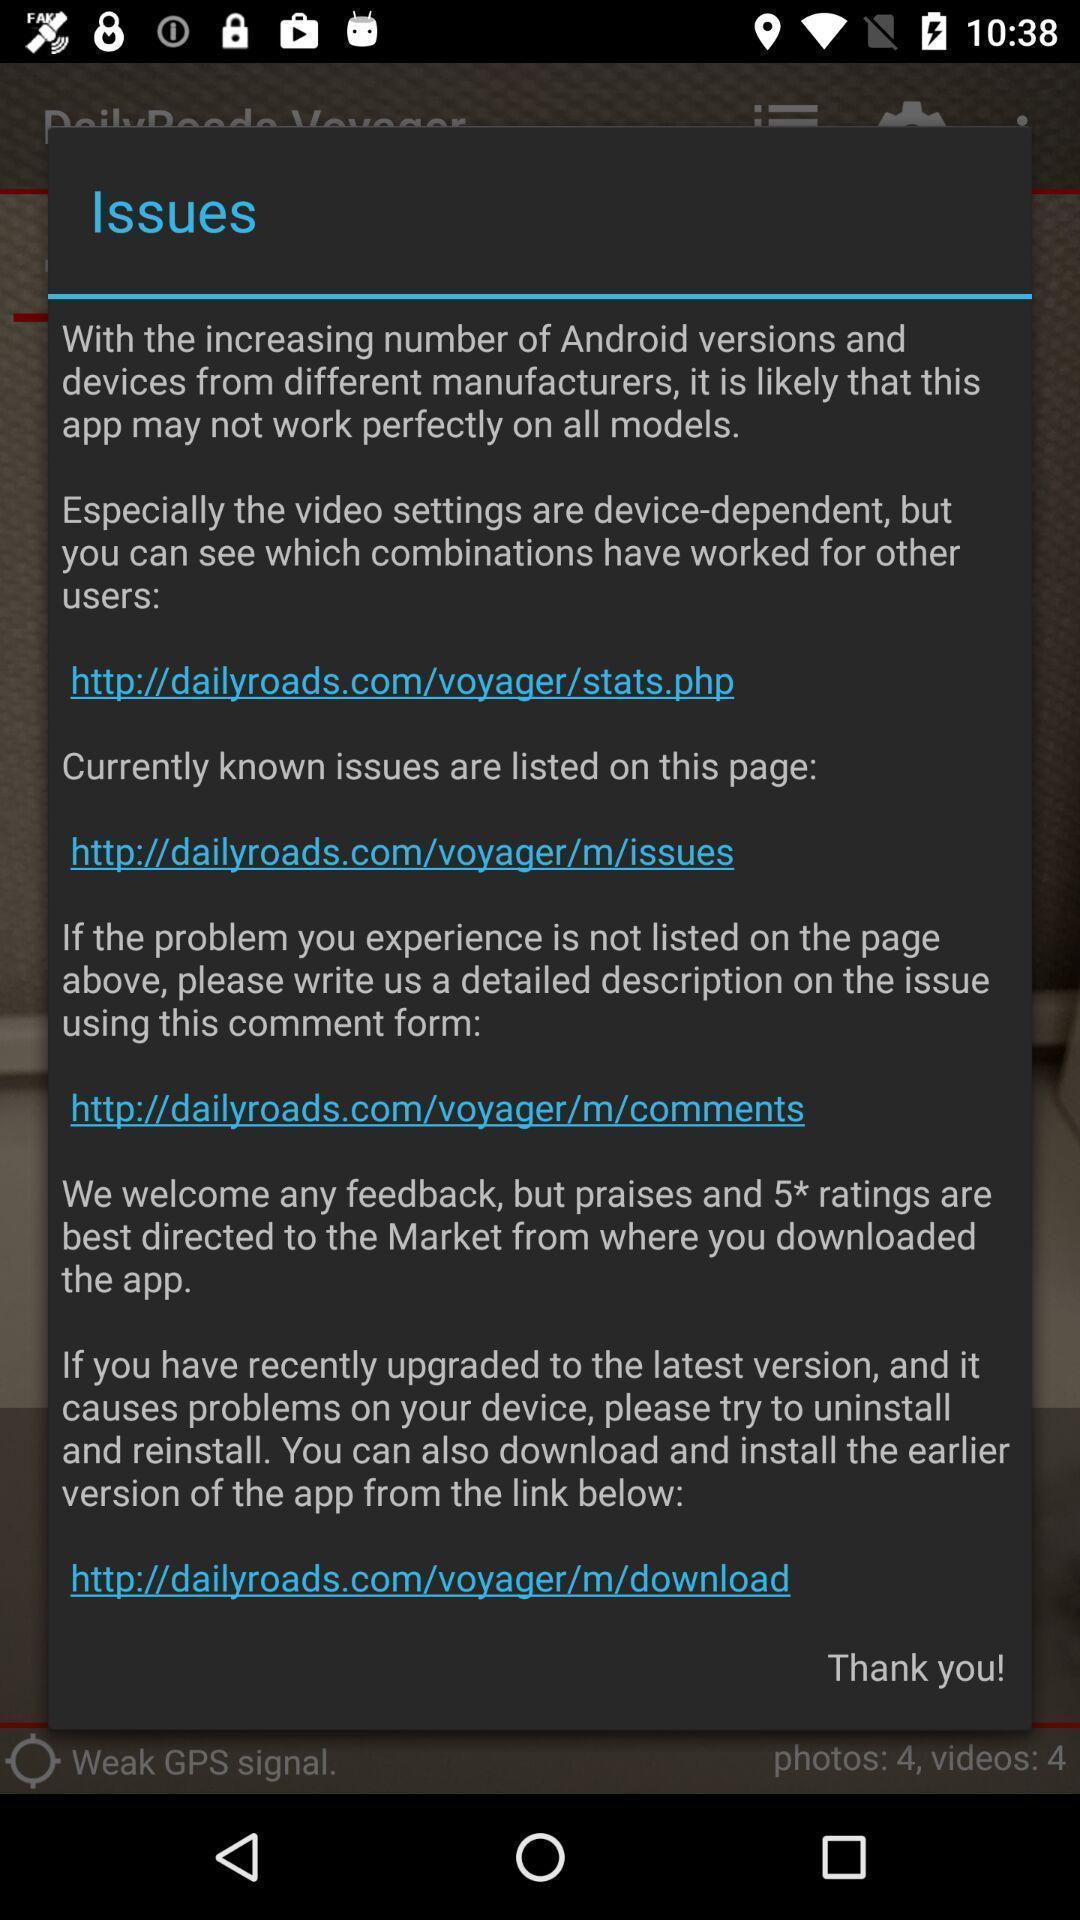Provide a description of this screenshot. Pop-up displaying with information about the different issues. 